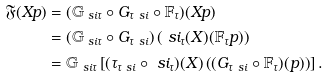<formula> <loc_0><loc_0><loc_500><loc_500>\mathfrak F ( X p ) & = ( \mathbb { G } _ { \ s i \tau } \circ G _ { \tau \ s i } \circ \mathbb { F } _ { \tau } ) ( X p ) \\ & = \left ( \mathbb { G } _ { \ s i \tau } \circ G _ { \tau \ s i } \right ) \left ( \ s i _ { \tau } ( X ) ( \mathbb { F } _ { \tau } p ) \right ) \\ & = \mathbb { G } _ { \ s i \tau } \left [ ( \tau _ { \tau \ s i } \circ \ s i _ { \tau } ) ( X ) \left ( ( G _ { \tau \ s i } \circ \mathbb { F } _ { \tau } ) ( p ) \right ) \right ] .</formula> 